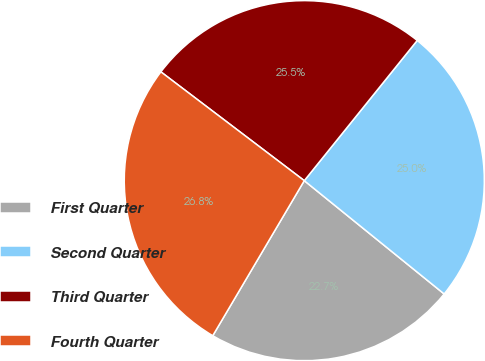Convert chart. <chart><loc_0><loc_0><loc_500><loc_500><pie_chart><fcel>First Quarter<fcel>Second Quarter<fcel>Third Quarter<fcel>Fourth Quarter<nl><fcel>22.65%<fcel>25.04%<fcel>25.46%<fcel>26.84%<nl></chart> 